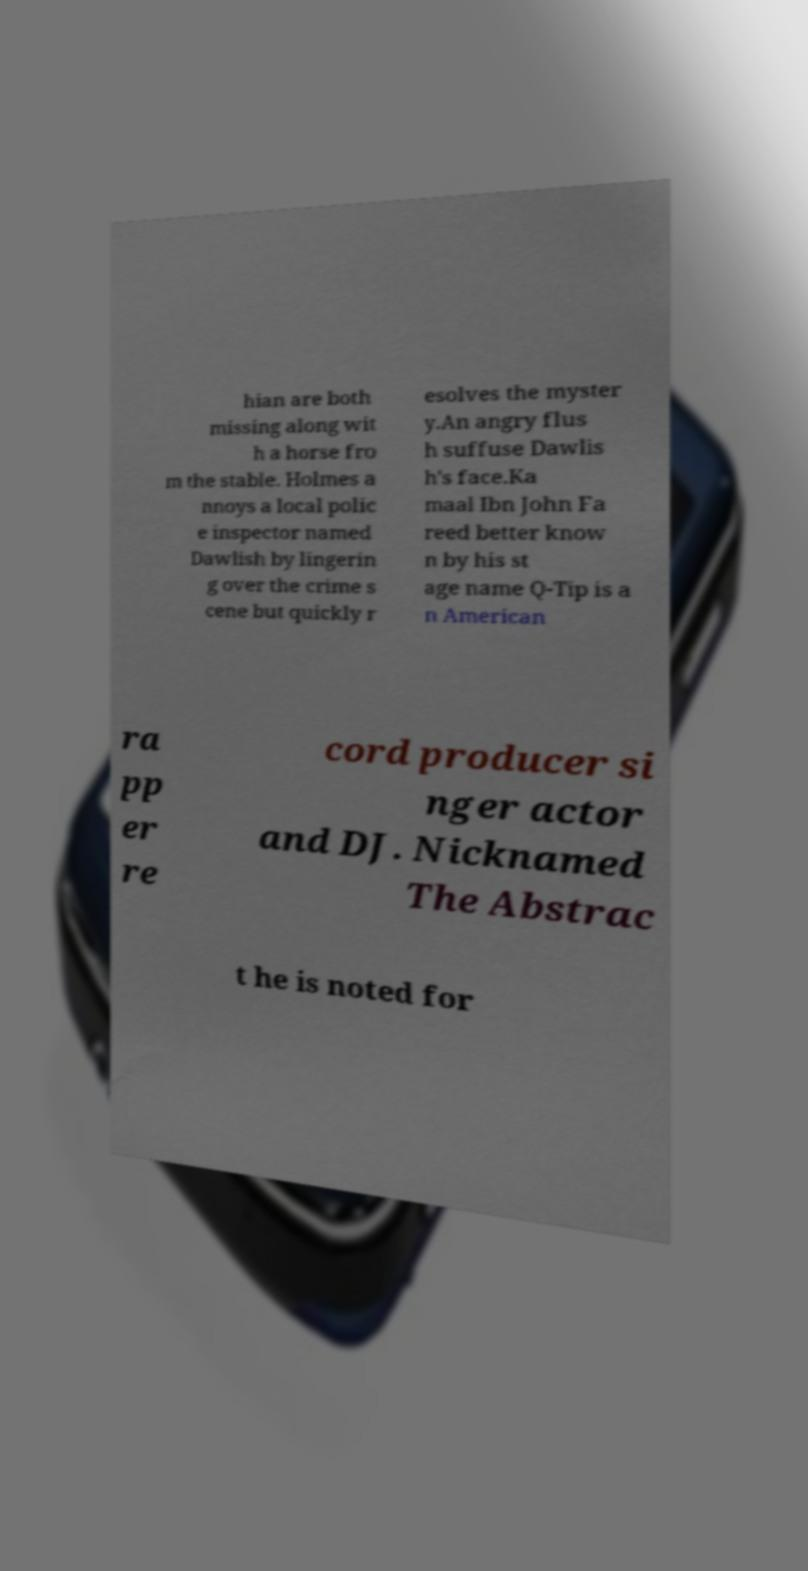There's text embedded in this image that I need extracted. Can you transcribe it verbatim? hian are both missing along wit h a horse fro m the stable. Holmes a nnoys a local polic e inspector named Dawlish by lingerin g over the crime s cene but quickly r esolves the myster y.An angry flus h suffuse Dawlis h's face.Ka maal Ibn John Fa reed better know n by his st age name Q-Tip is a n American ra pp er re cord producer si nger actor and DJ. Nicknamed The Abstrac t he is noted for 